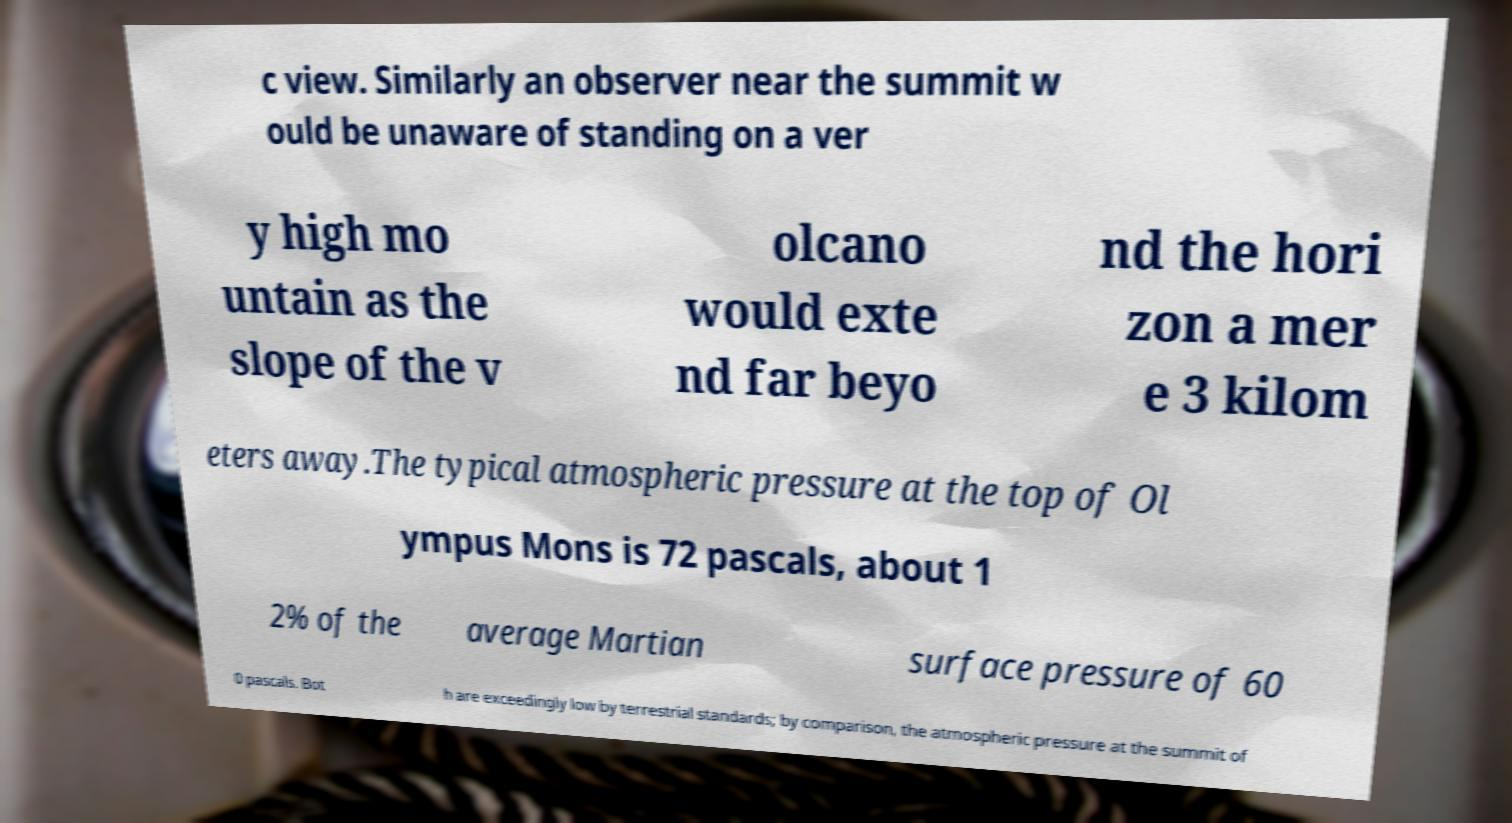For documentation purposes, I need the text within this image transcribed. Could you provide that? c view. Similarly an observer near the summit w ould be unaware of standing on a ver y high mo untain as the slope of the v olcano would exte nd far beyo nd the hori zon a mer e 3 kilom eters away.The typical atmospheric pressure at the top of Ol ympus Mons is 72 pascals, about 1 2% of the average Martian surface pressure of 60 0 pascals. Bot h are exceedingly low by terrestrial standards; by comparison, the atmospheric pressure at the summit of 